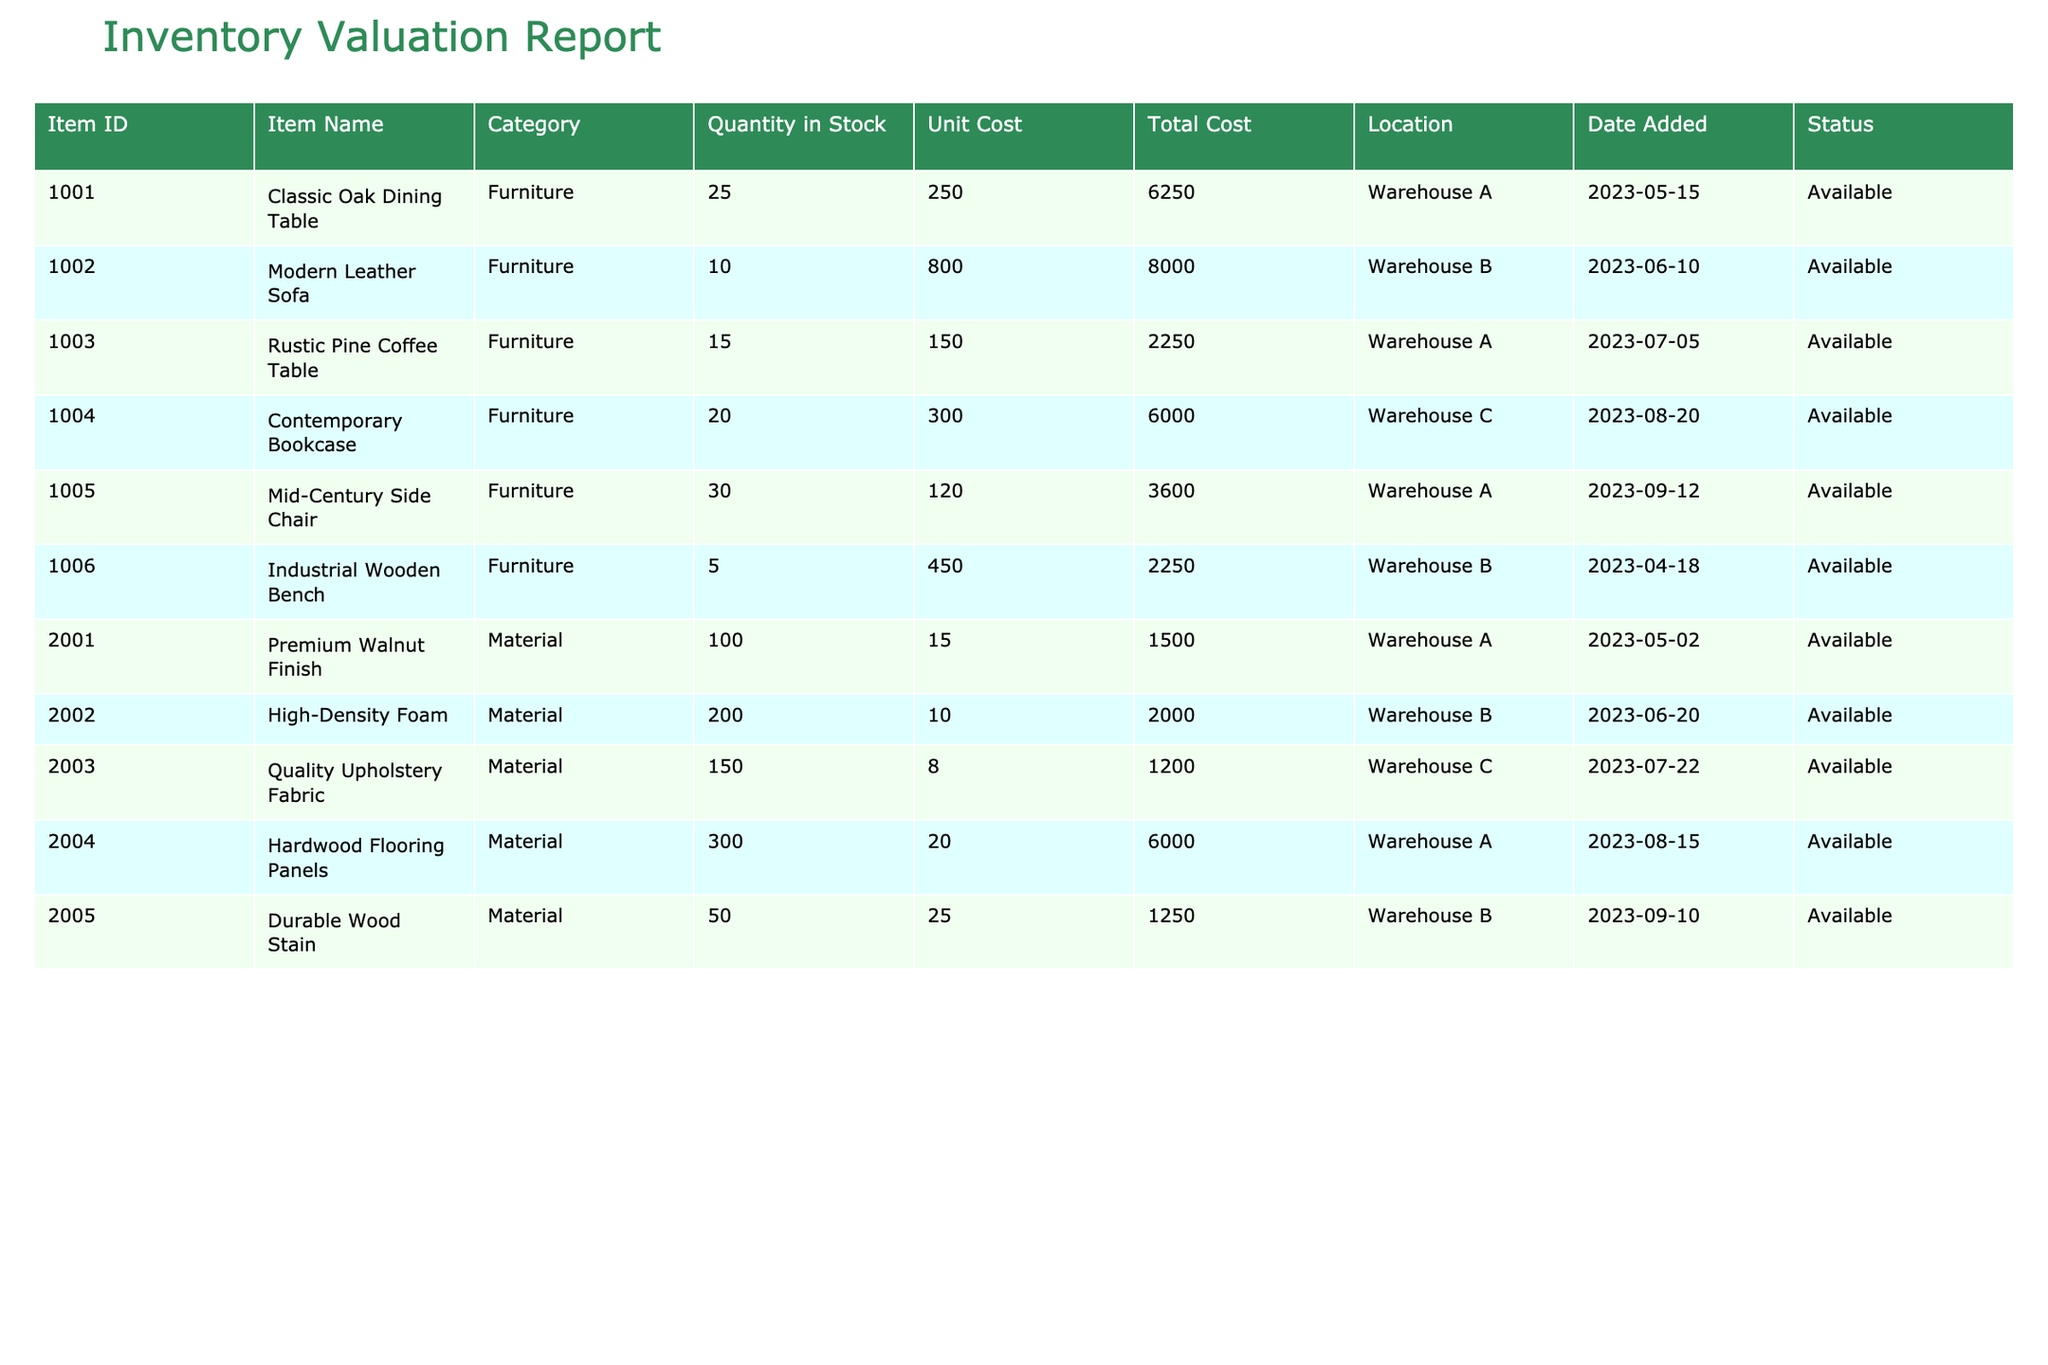What is the total quantity of finished goods in stock? The finished goods are classified under the category "Furniture." By summing the "Quantity in Stock" for all furniture items, we calculate: 25 (Classic Oak Dining Table) + 10 (Modern Leather Sofa) + 15 (Rustic Pine Coffee Table) + 20 (Contemporary Bookcase) + 30 (Mid-Century Side Chair) + 5 (Industrial Wooden Bench) = 105.
Answer: 105 Which material has the highest unit cost? Reviewing the "Unit Cost" column for materials, we find: Premium Walnut Finish (15), High-Density Foam (10), Quality Upholstery Fabric (8), Hardwood Flooring Panels (20), and Durable Wood Stain (25). The highest cost is for Durable Wood Stain, which is 25.
Answer: Durable Wood Stain Is there any item in stock with a quantity of less than 10? Looking at the "Quantity in Stock" for all items, only the Industrial Wooden Bench has a quantity of 5, which is less than 10. Thus, the answer is true.
Answer: Yes What is the total cost of all materials in stock? To find the total cost of materials, we sum the "Total Cost" for each material item: 1500 (Premium Walnut Finish) + 2000 (High-Density Foam) + 1200 (Quality Upholstery Fabric) + 6000 (Hardwood Flooring Panels) + 1250 (Durable Wood Stain) = 12950.
Answer: 12950 How many items are located in Warehouse A? By examining the "Location" column, we see that the following items are in Warehouse A: Classic Oak Dining Table, Premium Walnut Finish, Hardwood Flooring Panels, and Mid-Century Side Chair. This gives us a total of 4 items.
Answer: 4 What percentage of the total inventory cost does the Classic Oak Dining Table represent? The total inventory cost can be computed by summing the "Total Cost" for all items: 6250 (Classic Oak Dining Table) + 8000 (Modern Leather Sofa) + 2250 (Rustic Pine Coffee Table) + 6000 (Contemporary Bookcase) + 3600 (Mid-Century Side Chair) + 2250 (Industrial Wooden Bench) + 1500 (Premium Walnut Finish) + 2000 (High-Density Foam) + 1200 (Quality Upholstery Fabric) + 6000 (Hardwood Flooring Panels) + 1250 (Durable Wood Stain) = 25000. Therefore, the percentage is (6250 / 25000) * 100 = 25%.
Answer: 25% Are all items in the inventory listed as 'Available'? Reviewing the "Status" column for all items, we see that each item is listed as 'Available.' Therefore, the answer is yes.
Answer: Yes What is the average unit cost of the materials? The unit costs for materials are: 15 (Premium Walnut Finish), 10 (High-Density Foam), 8 (Quality Upholstery Fabric), 20 (Hardwood Flooring Panels), and 25 (Durable Wood Stain). To find the average, we sum these values (15 + 10 + 8 + 20 + 25 = 78) and then divide by the number of materials (5). The average is 78 / 5 = 15.6.
Answer: 15.6 